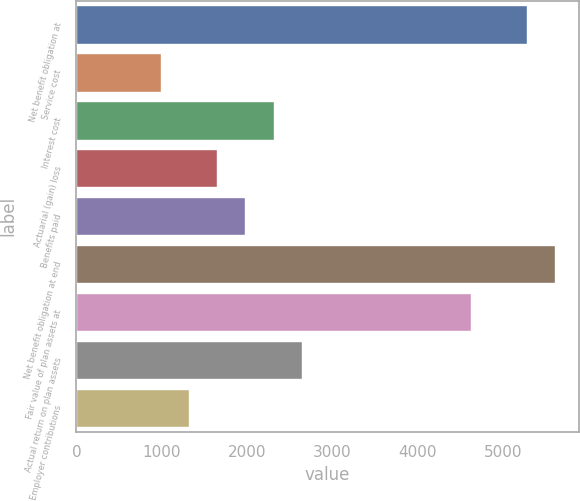Convert chart. <chart><loc_0><loc_0><loc_500><loc_500><bar_chart><fcel>Net benefit obligation at<fcel>Service cost<fcel>Interest cost<fcel>Actuarial (gain) loss<fcel>Benefits paid<fcel>Net benefit obligation at end<fcel>Fair value of plan assets at<fcel>Actual return on plan assets<fcel>Employer contributions<nl><fcel>5283.6<fcel>992.3<fcel>2312.7<fcel>1652.5<fcel>1982.6<fcel>5613.7<fcel>4623.4<fcel>2642.8<fcel>1322.4<nl></chart> 